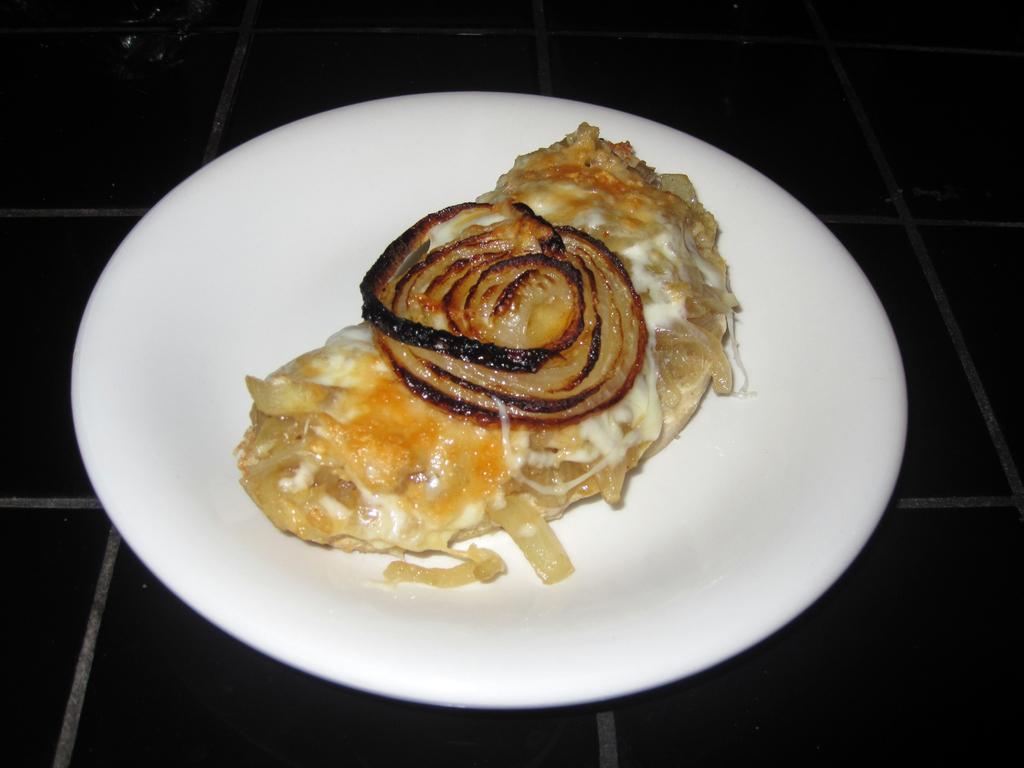In one or two sentences, can you explain what this image depicts? In this image there are food items in a plate which was placed on the floor. 